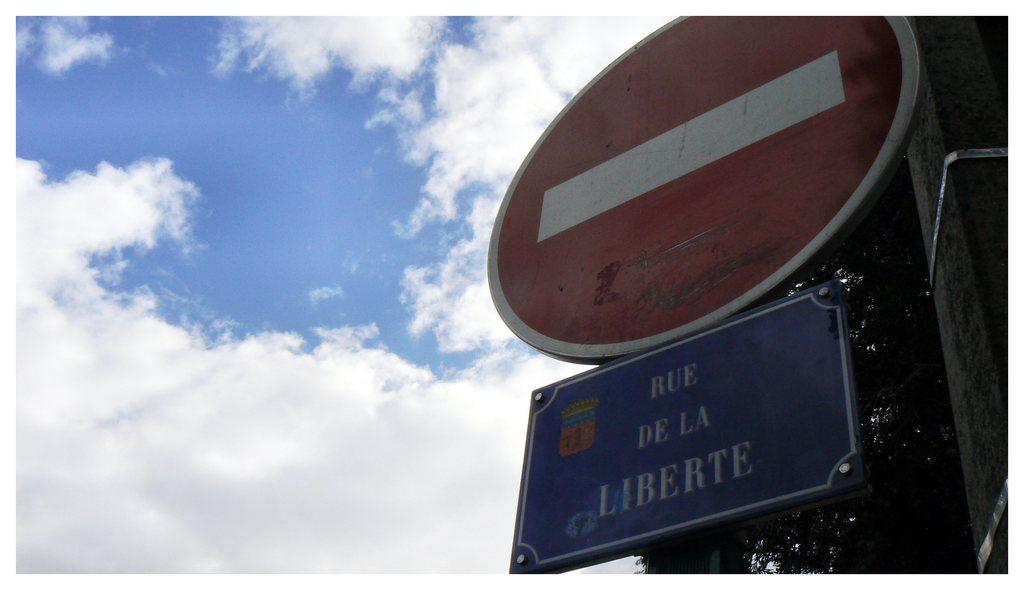What is the first word on the blue sign?
Ensure brevity in your answer.  Rue. What is the last letter on the sign?
Give a very brief answer. E. 